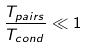Convert formula to latex. <formula><loc_0><loc_0><loc_500><loc_500>\frac { T _ { p a i r s } } { T _ { c o n d } } \ll 1</formula> 